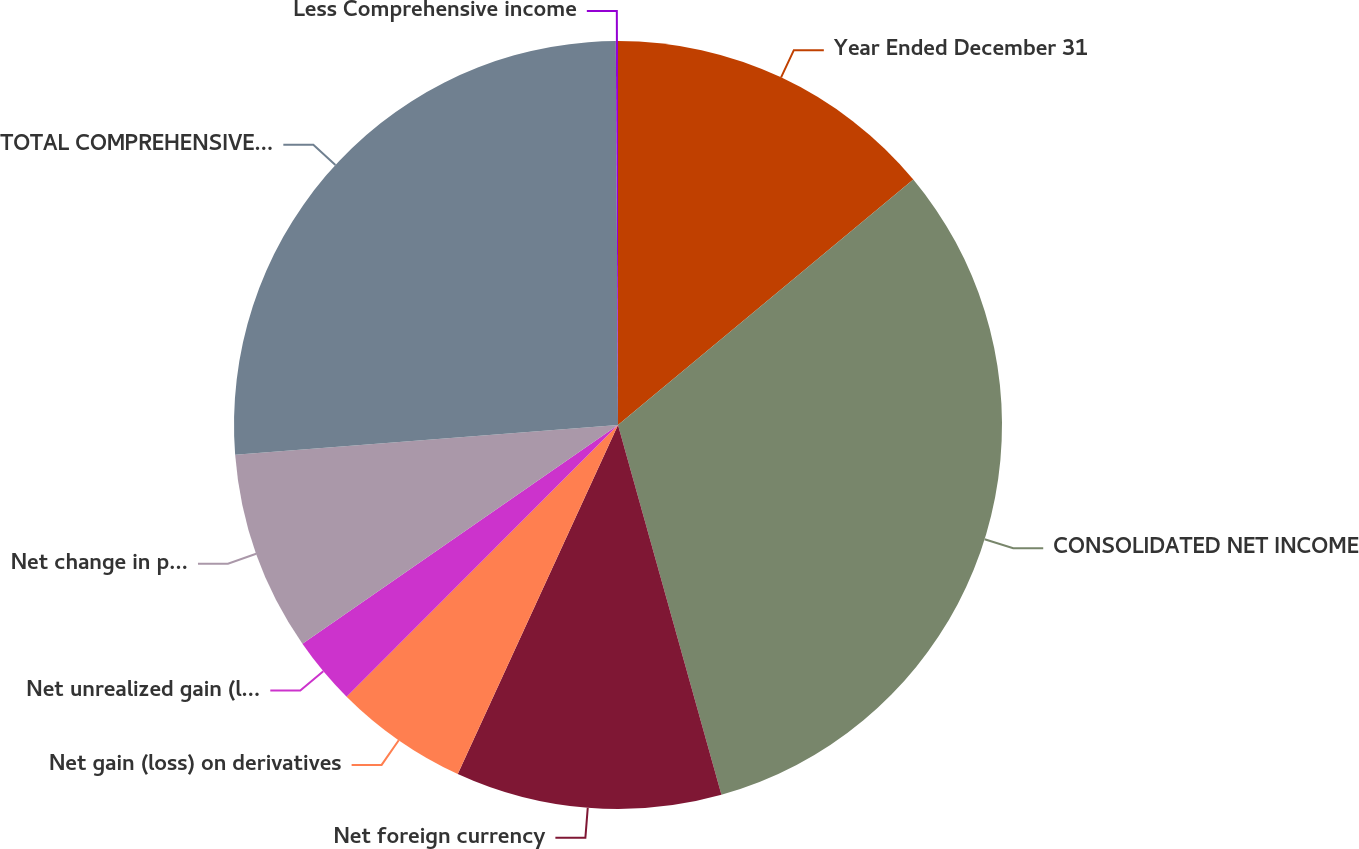Convert chart. <chart><loc_0><loc_0><loc_500><loc_500><pie_chart><fcel>Year Ended December 31<fcel>CONSOLIDATED NET INCOME<fcel>Net foreign currency<fcel>Net gain (loss) on derivatives<fcel>Net unrealized gain (loss) on<fcel>Net change in pension and<fcel>TOTAL COMPREHENSIVE INCOME<fcel>Less Comprehensive income<nl><fcel>13.96%<fcel>31.69%<fcel>11.19%<fcel>5.64%<fcel>2.86%<fcel>8.41%<fcel>26.14%<fcel>0.09%<nl></chart> 